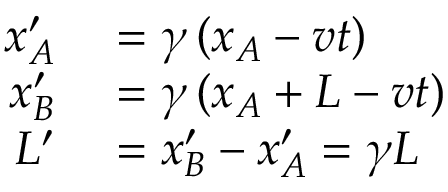Convert formula to latex. <formula><loc_0><loc_0><loc_500><loc_500>\begin{array} { r l } { x _ { A } ^ { \prime } } & = \gamma \left ( x _ { A } - v t \right ) } \\ { x _ { B } ^ { \prime } } & = \gamma \left ( x _ { A } + L - v t \right ) } \\ { L ^ { \prime } } & = x _ { B } ^ { \prime } - x _ { A } ^ { \prime } = \gamma L } \end{array}</formula> 